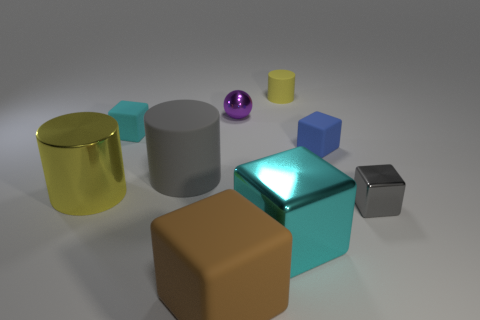Subtract all red blocks. Subtract all yellow balls. How many blocks are left? 5 Subtract all cylinders. How many objects are left? 6 Subtract 0 gray balls. How many objects are left? 9 Subtract all tiny green cubes. Subtract all cylinders. How many objects are left? 6 Add 5 big cyan cubes. How many big cyan cubes are left? 6 Add 1 tiny gray shiny things. How many tiny gray shiny things exist? 2 